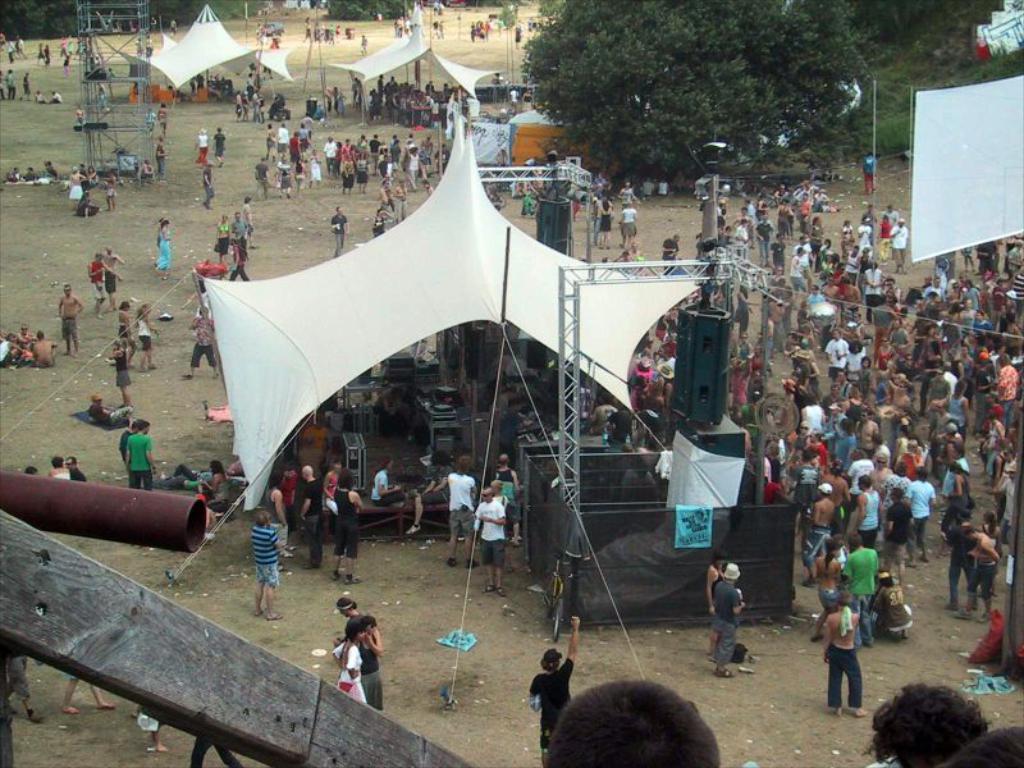Please provide a concise description of this image. In this picture we can see a group of people standing on the path and on the path there are stalls, trees and other items. 